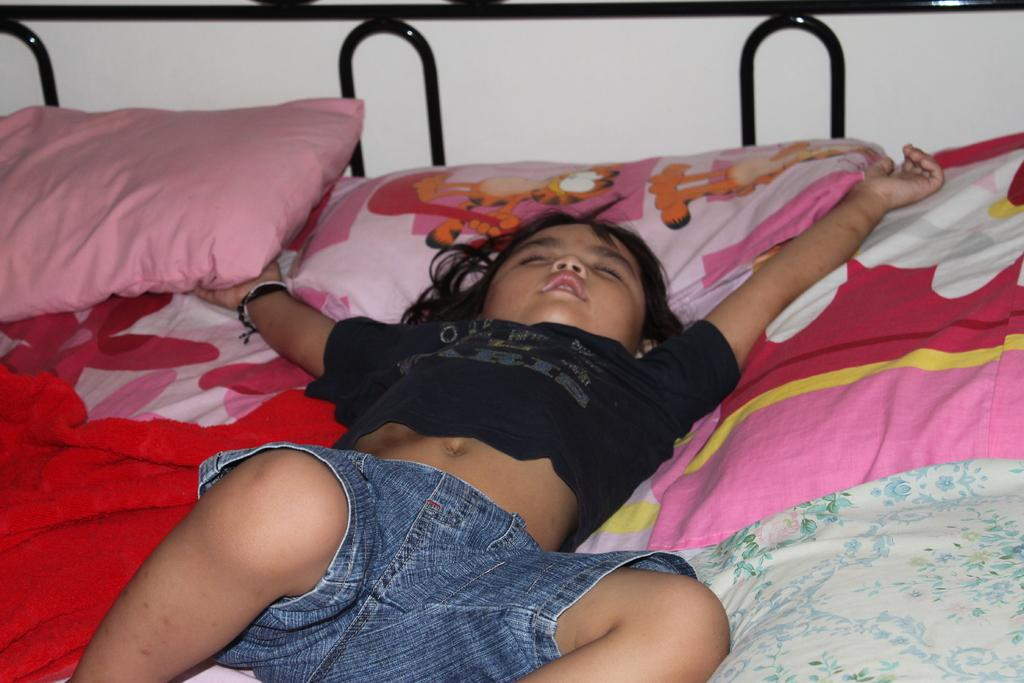Who is in the image? There is a girl in the image. What is the girl wearing? The girl is wearing a black shirt and blue shorts. What is the girl doing in the image? The girl is sleeping. What can be seen on the bed? The bed has pillows on it. What colors are present on the bed sheet? The bed sheet has pink, yellow, orange, and white colors. What type of trousers is the girl wearing in the image? The girl is not wearing trousers in the image; she is wearing blue shorts. What part of the girl's body is exposed in the image? The image does not show any exposed flesh, as the girl is fully clothed in a black shirt and blue shorts. 